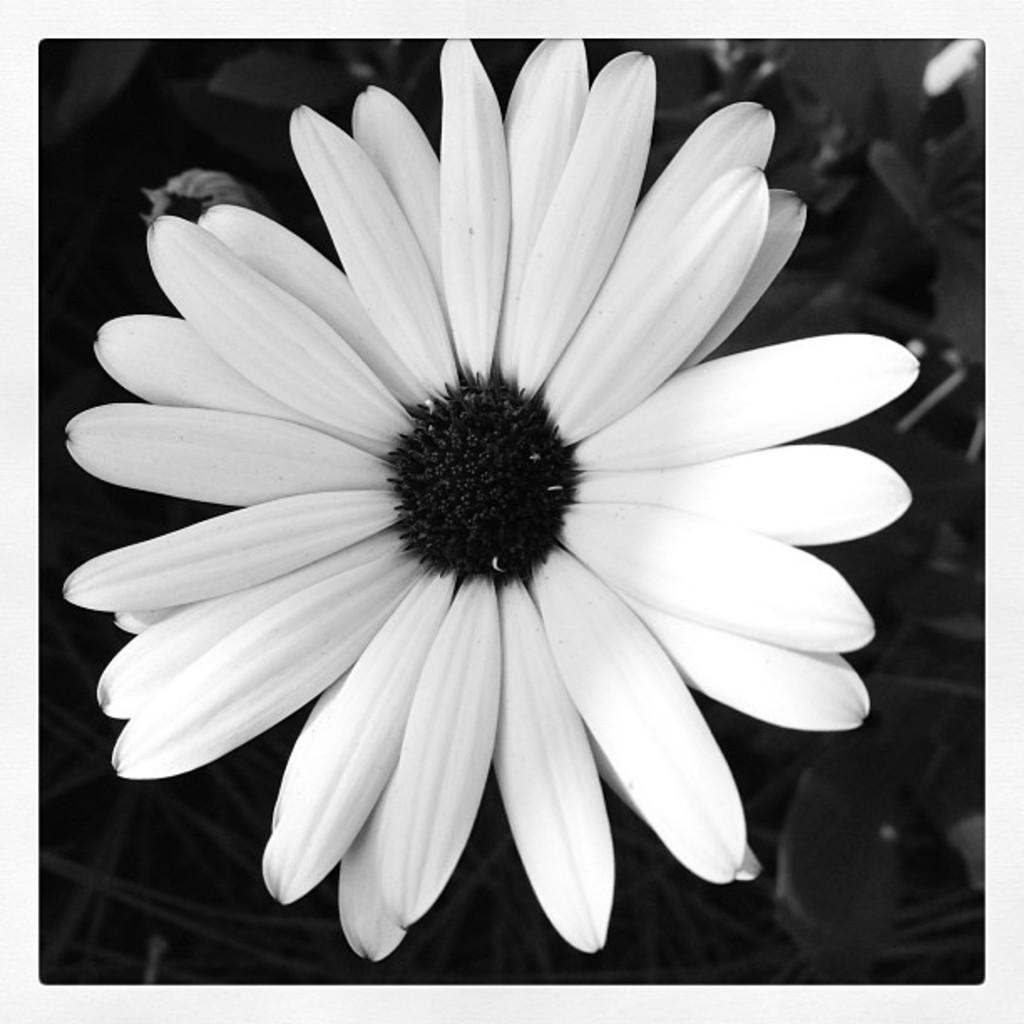What type of living organism can be seen in the image? There is a plant in the image. What specific feature can be observed on the plant? There is a flower on the plant. What is the color of the flower? The flower is white in color. Are there any fairies dancing around the white flower in the image? There is no indication of fairies or any other mythical creatures in the image; it only features a plant with a white flower. 